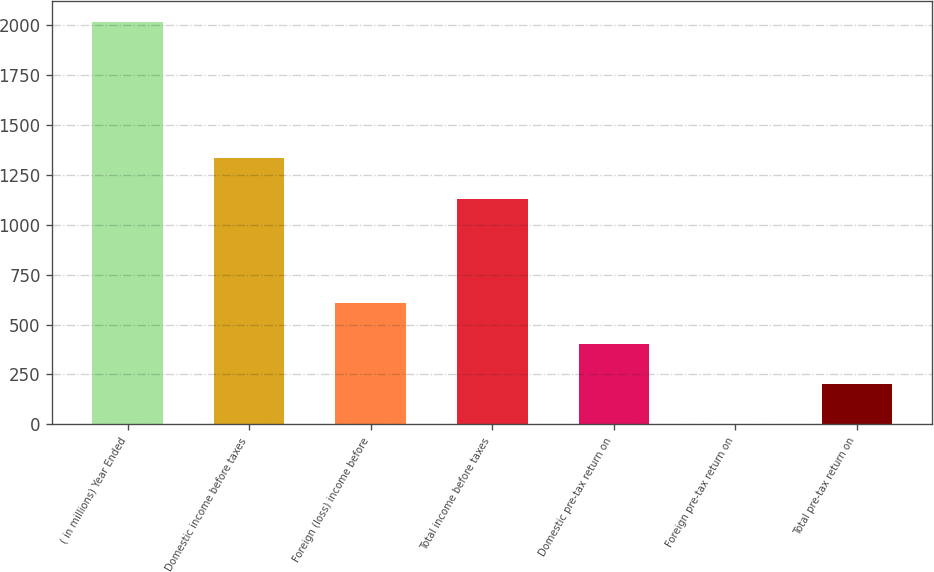Convert chart to OTSL. <chart><loc_0><loc_0><loc_500><loc_500><bar_chart><fcel>( in millions) Year Ended<fcel>Domestic income before taxes<fcel>Foreign (loss) income before<fcel>Total income before taxes<fcel>Domestic pre-tax return on<fcel>Foreign pre-tax return on<fcel>Total pre-tax return on<nl><fcel>2016<fcel>1331.92<fcel>605.36<fcel>1130.4<fcel>403.84<fcel>0.8<fcel>202.32<nl></chart> 